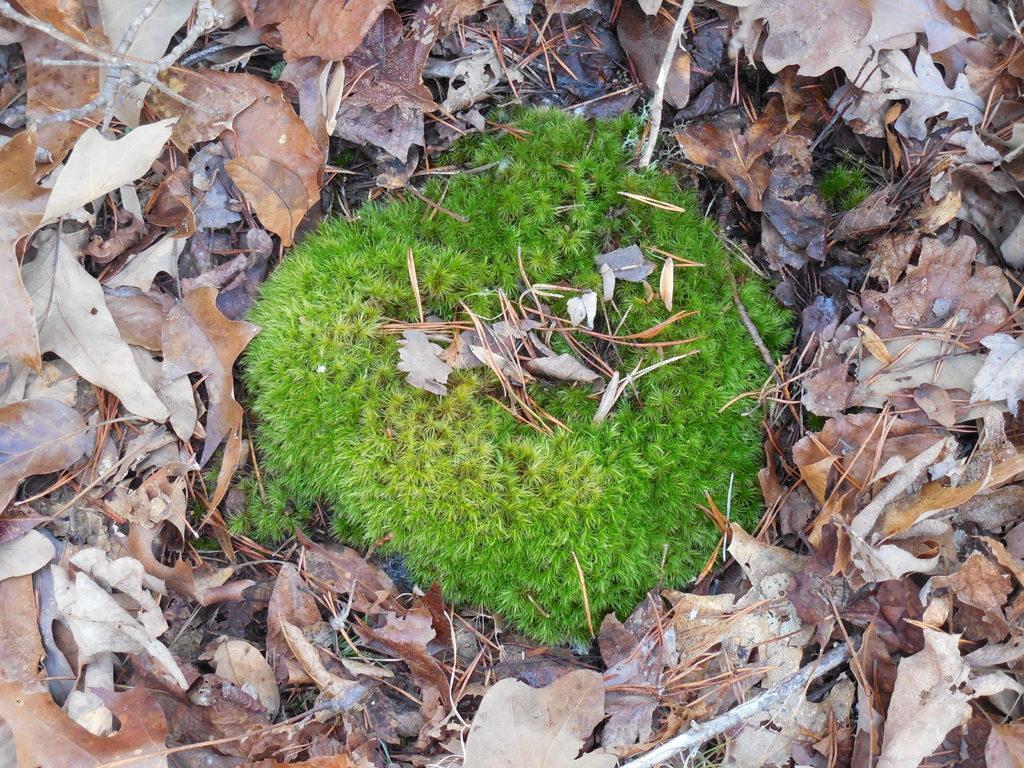In one or two sentences, can you explain what this image depicts? In this picture we can see grass and dried leaves on the ground. 